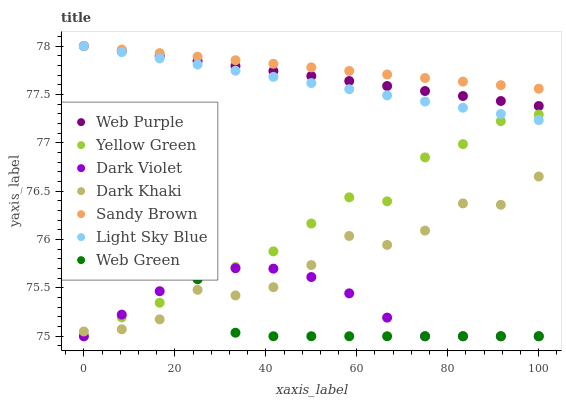Does Web Green have the minimum area under the curve?
Answer yes or no. Yes. Does Sandy Brown have the maximum area under the curve?
Answer yes or no. Yes. Does Dark Violet have the minimum area under the curve?
Answer yes or no. No. Does Dark Violet have the maximum area under the curve?
Answer yes or no. No. Is Sandy Brown the smoothest?
Answer yes or no. Yes. Is Dark Khaki the roughest?
Answer yes or no. Yes. Is Dark Violet the smoothest?
Answer yes or no. No. Is Dark Violet the roughest?
Answer yes or no. No. Does Yellow Green have the lowest value?
Answer yes or no. Yes. Does Dark Khaki have the lowest value?
Answer yes or no. No. Does Sandy Brown have the highest value?
Answer yes or no. Yes. Does Dark Khaki have the highest value?
Answer yes or no. No. Is Dark Violet less than Sandy Brown?
Answer yes or no. Yes. Is Light Sky Blue greater than Dark Violet?
Answer yes or no. Yes. Does Yellow Green intersect Light Sky Blue?
Answer yes or no. Yes. Is Yellow Green less than Light Sky Blue?
Answer yes or no. No. Is Yellow Green greater than Light Sky Blue?
Answer yes or no. No. Does Dark Violet intersect Sandy Brown?
Answer yes or no. No. 